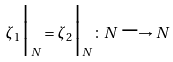<formula> <loc_0><loc_0><loc_500><loc_500>\zeta _ { 1 } \Big { | } _ { N } = \zeta _ { 2 } \Big { | } _ { N } \colon N \longrightarrow N</formula> 